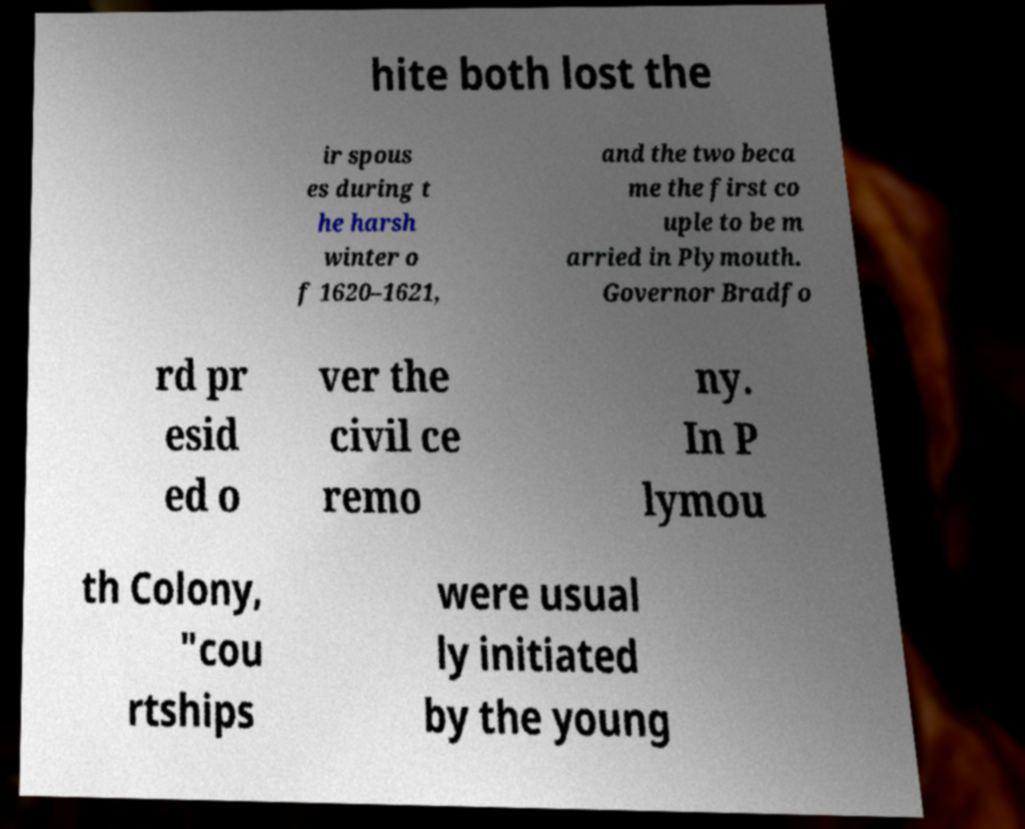Could you extract and type out the text from this image? hite both lost the ir spous es during t he harsh winter o f 1620–1621, and the two beca me the first co uple to be m arried in Plymouth. Governor Bradfo rd pr esid ed o ver the civil ce remo ny. In P lymou th Colony, "cou rtships were usual ly initiated by the young 